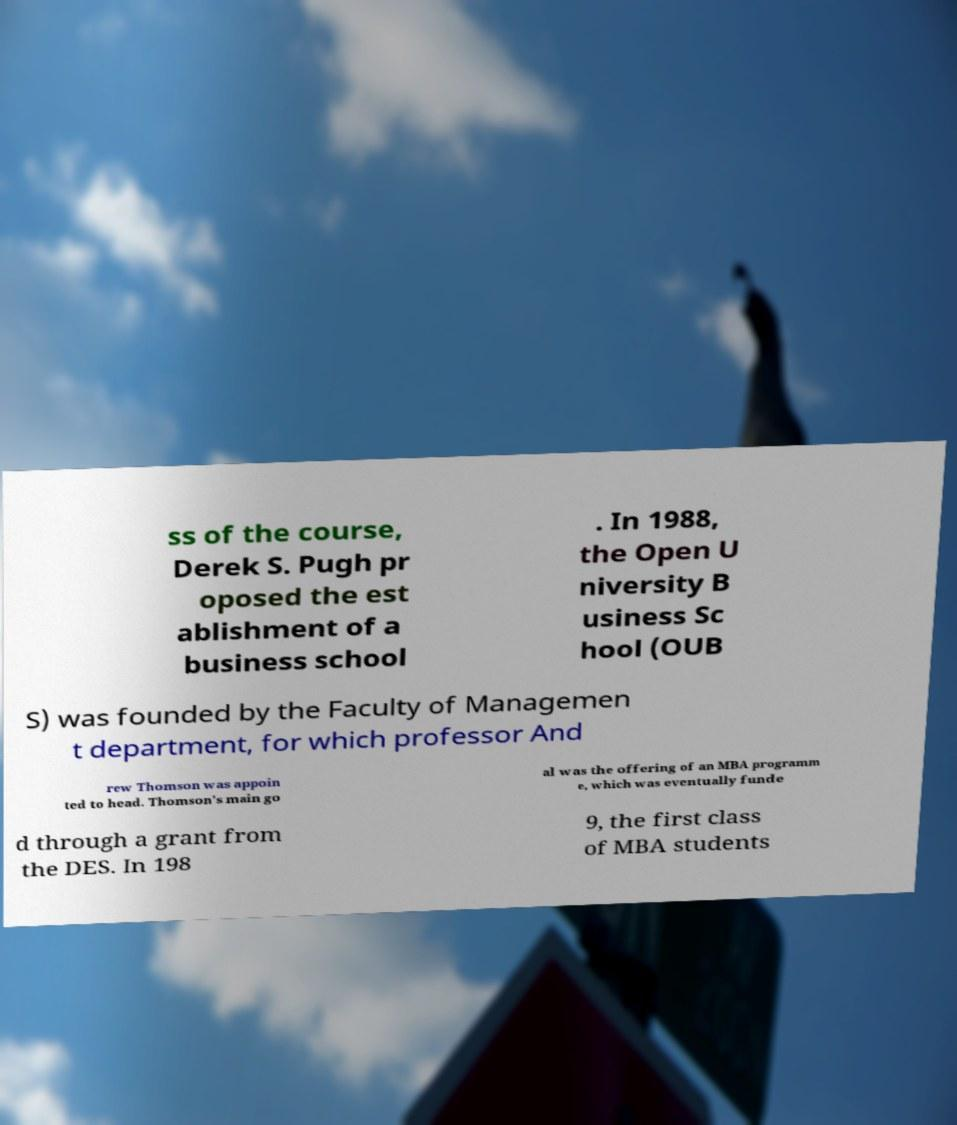Please read and relay the text visible in this image. What does it say? ss of the course, Derek S. Pugh pr oposed the est ablishment of a business school . In 1988, the Open U niversity B usiness Sc hool (OUB S) was founded by the Faculty of Managemen t department, for which professor And rew Thomson was appoin ted to head. Thomson's main go al was the offering of an MBA programm e, which was eventually funde d through a grant from the DES. In 198 9, the first class of MBA students 